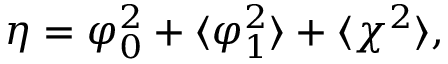Convert formula to latex. <formula><loc_0><loc_0><loc_500><loc_500>\eta = \varphi _ { 0 } ^ { 2 } + \langle \varphi _ { 1 } ^ { 2 } \rangle + \langle \chi ^ { 2 } \rangle ,</formula> 